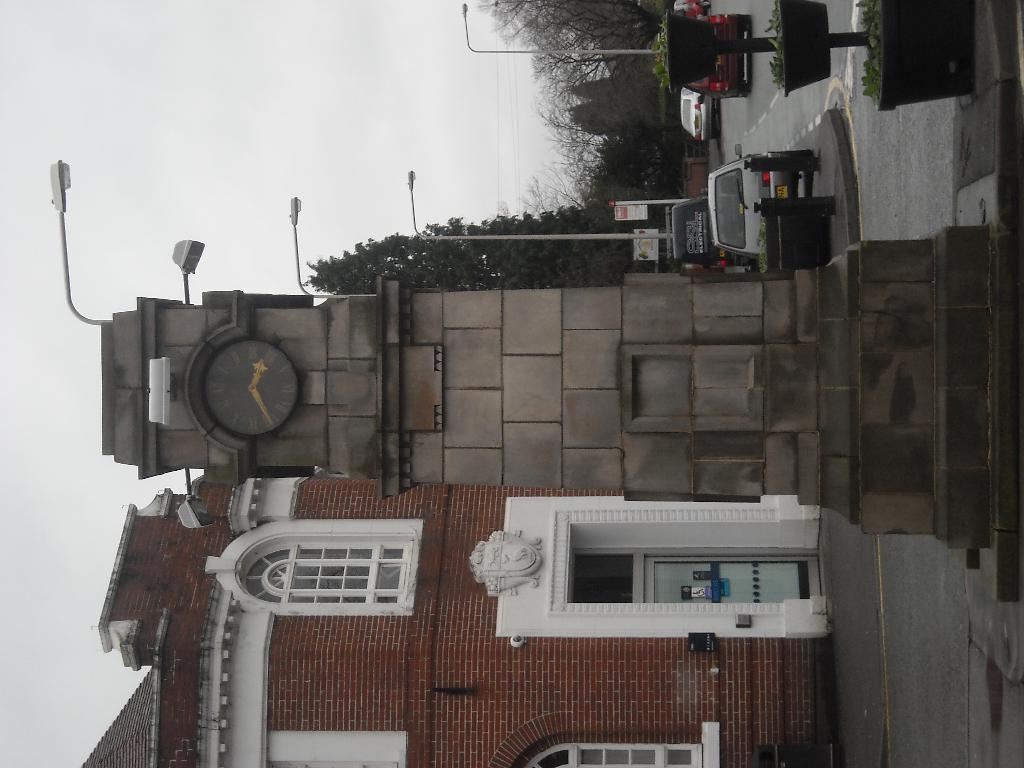What is the tall structure in the image? There is a clock tower in the image. What can be seen on the ground in the image? There are vehicles on the road in the image. What type of structures are present in the image? There are buildings in the image. What are the vertical structures with lights on them? There are light poles in the image. What type of vegetation is present in the image? There are trees and plants with pots in the image. What are the flat, rectangular objects in the image? There are boards in the image. What is visible in the background of the image? The sky is visible in the background of the image. What type of skirt is hanging from the light poles in the image? There are no skirts present in the image; the light poles are vertical structures with lights on them. How does the wind affect the beds in the image? There are no beds present in the image, so the wind's effect cannot be determined. 